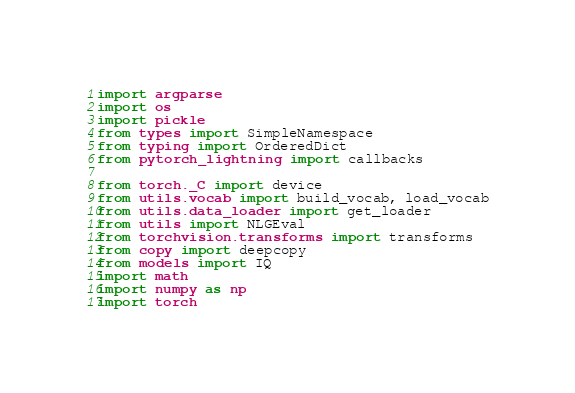<code> <loc_0><loc_0><loc_500><loc_500><_Python_>import argparse
import os
import pickle
from types import SimpleNamespace
from typing import OrderedDict
from pytorch_lightning import callbacks

from torch._C import device
from utils.vocab import build_vocab, load_vocab
from utils.data_loader import get_loader
from utils import NLGEval
from torchvision.transforms import transforms
from copy import deepcopy
from models import IQ
import math
import numpy as np
import torch</code> 